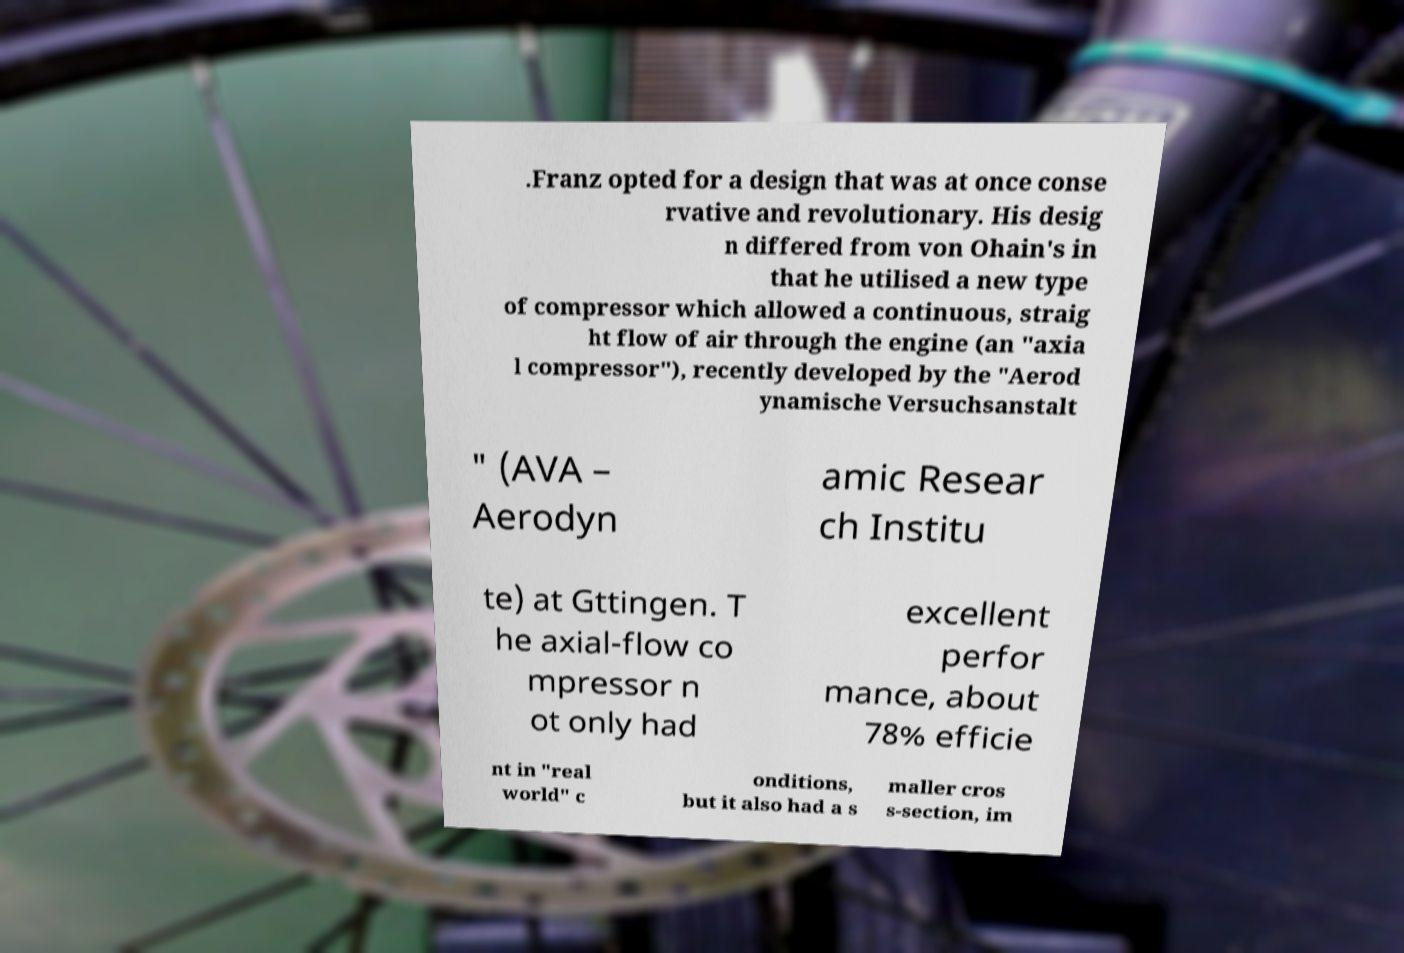Can you accurately transcribe the text from the provided image for me? .Franz opted for a design that was at once conse rvative and revolutionary. His desig n differed from von Ohain's in that he utilised a new type of compressor which allowed a continuous, straig ht flow of air through the engine (an "axia l compressor"), recently developed by the "Aerod ynamische Versuchsanstalt " (AVA – Aerodyn amic Resear ch Institu te) at Gttingen. T he axial-flow co mpressor n ot only had excellent perfor mance, about 78% efficie nt in "real world" c onditions, but it also had a s maller cros s-section, im 